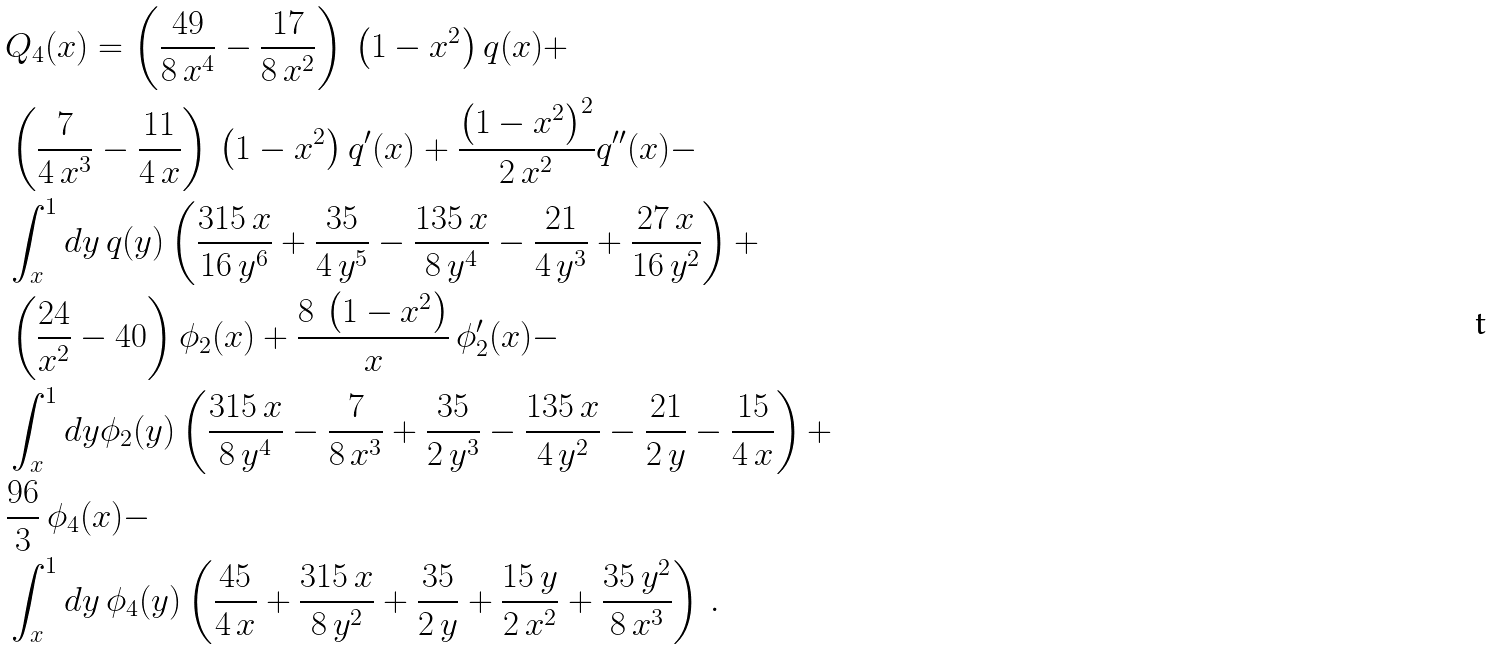Convert formula to latex. <formula><loc_0><loc_0><loc_500><loc_500>& Q _ { 4 } ( x ) = \left ( \frac { 4 9 } { 8 \, x ^ { 4 } } - \frac { 1 7 } { 8 \, x ^ { 2 } } \right ) \, \left ( 1 - x ^ { 2 } \right ) q ( x ) + \\ & \left ( \frac { 7 } { 4 \, x ^ { 3 } } - \frac { 1 1 } { 4 \, x } \right ) \, \left ( 1 - x ^ { 2 } \right ) q ^ { \prime } ( x ) + \frac { { \left ( 1 - x ^ { 2 } \right ) } ^ { 2 } } { 2 \, x ^ { 2 } } q ^ { \prime \prime } ( x ) - \\ & \int _ { x } ^ { 1 } d y \, q ( y ) \left ( \frac { 3 1 5 \, x } { 1 6 \, y ^ { 6 } } + \frac { 3 5 } { 4 \, y ^ { 5 } } - \frac { 1 3 5 \, x } { 8 \, y ^ { 4 } } - \frac { 2 1 } { 4 \, y ^ { 3 } } + \frac { 2 7 \, x } { 1 6 \, y ^ { 2 } } \right ) + \\ & \left ( \frac { 2 4 } { x ^ { 2 } } - 4 0 \right ) \phi _ { 2 } ( x ) + \frac { 8 \, \left ( 1 - x ^ { 2 } \right ) } { x } \, \phi _ { 2 } ^ { \prime } ( x ) - \\ & \int _ { x } ^ { 1 } d y \phi _ { 2 } ( y ) \left ( \frac { 3 1 5 \, x } { 8 \, y ^ { 4 } } - \frac { 7 } { 8 \, x ^ { 3 } } + \frac { 3 5 } { 2 \, y ^ { 3 } } - \frac { 1 3 5 \, x } { 4 \, y ^ { 2 } } - \frac { 2 1 } { 2 \, y } - \frac { 1 5 } { 4 \, x } \right ) + \\ & \frac { 9 6 } { 3 } \, \phi _ { 4 } ( x ) - \\ & \int _ { x } ^ { 1 } d y \, \phi _ { 4 } ( y ) \left ( \frac { 4 5 } { 4 \, x } + \frac { 3 1 5 \, x } { 8 \, y ^ { 2 } } + \frac { 3 5 } { 2 \, y } + \frac { 1 5 \, y } { 2 \, x ^ { 2 } } + \frac { 3 5 \, y ^ { 2 } } { 8 \, x ^ { 3 } } \right ) \, .</formula> 